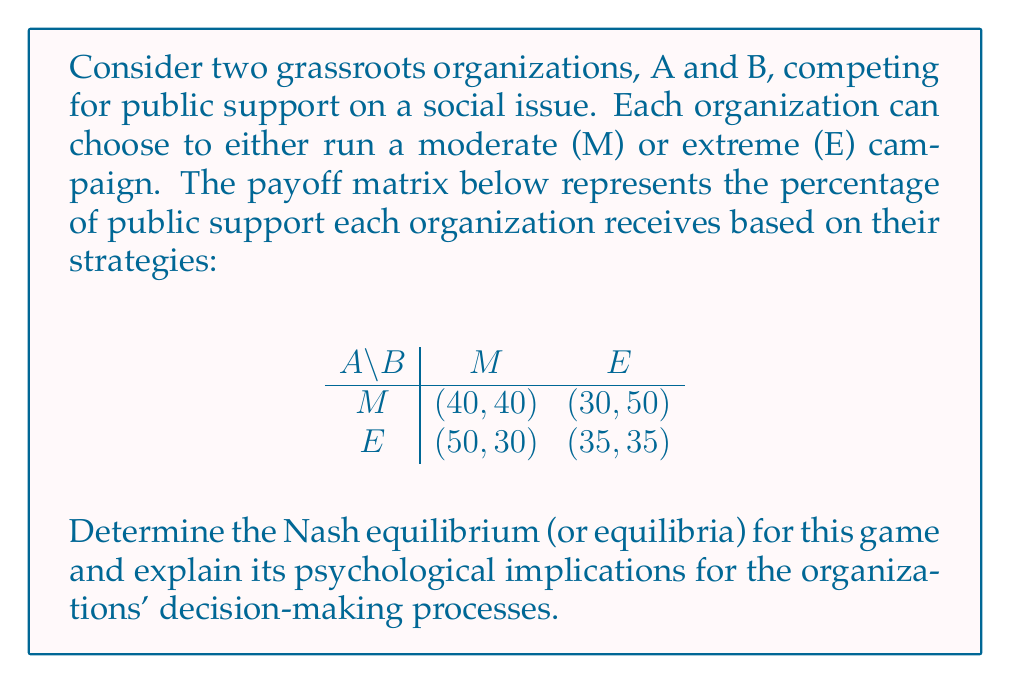What is the answer to this math problem? To find the Nash equilibrium, we need to identify the strategy profiles where neither player has an incentive to unilaterally deviate from their chosen strategy.

Step 1: Analyze Organization A's best responses
- If B chooses M, A's best response is E (50 > 40)
- If B chooses E, A's best response is E (35 > 30)

Step 2: Analyze Organization B's best responses
- If A chooses M, B's best response is E (50 > 40)
- If A chooses E, B's best response is M (30 > 35)

Step 3: Identify Nash equilibrium
The only strategy profile that satisfies both organizations' best responses is (E, M), where A chooses E and B chooses M.

Psychological implications:
1. Asymmetric equilibrium: The Nash equilibrium suggests that one organization (A) will adopt an extreme stance while the other (B) maintains a moderate position. This reflects the psychological tendency for organizations to differentiate themselves in competitive environments.

2. First-mover advantage: Organization A gains an advantage by choosing an extreme strategy, which may indicate a psychological bias towards bold, attention-grabbing tactics in grassroots movements.

3. Risk-reward trade-off: The payoff matrix shows that choosing an extreme strategy carries both higher potential gains and losses, reflecting the psychological tension between risk-taking and risk-aversion in decision-making.

4. Strategic interdependence: The equilibrium demonstrates how each organization's optimal strategy depends on the other's choice, highlighting the importance of anticipating competitors' actions in grassroots campaign planning.

5. Polarization dynamics: The asymmetric equilibrium may contribute to a more polarized public discourse, as one organization maintains an extreme position while the other remains moderate.
Answer: The Nash equilibrium for this game is (E, M), where Organization A chooses the Extreme strategy and Organization B chooses the Moderate strategy. This equilibrium reflects the complex psychological dynamics of competition and strategic decision-making in grassroots movements. 